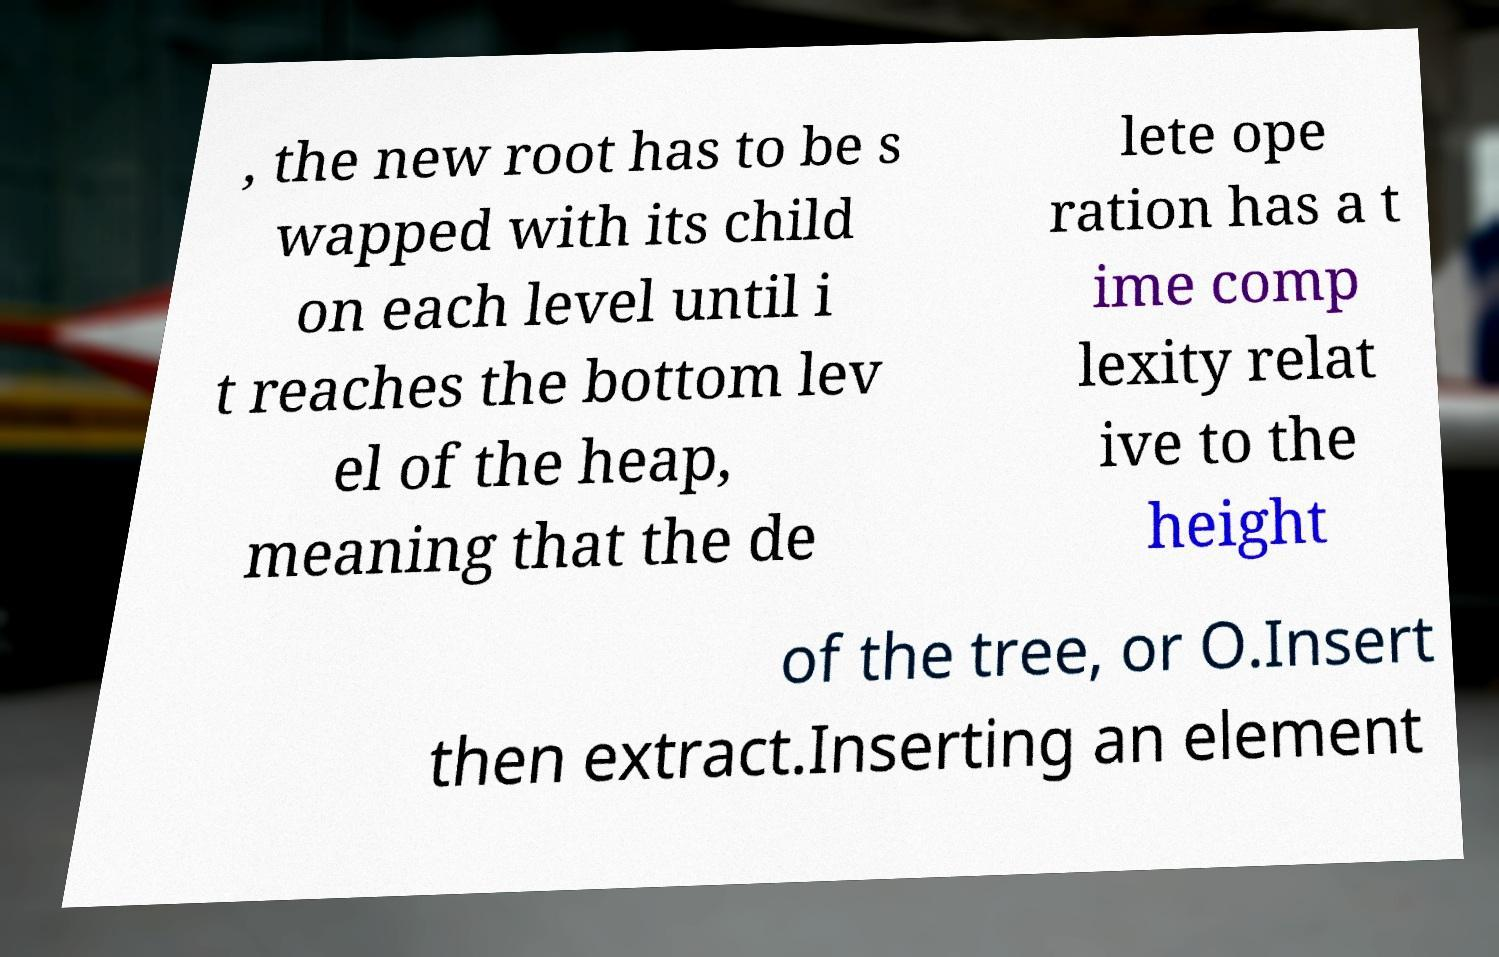Could you extract and type out the text from this image? , the new root has to be s wapped with its child on each level until i t reaches the bottom lev el of the heap, meaning that the de lete ope ration has a t ime comp lexity relat ive to the height of the tree, or O.Insert then extract.Inserting an element 